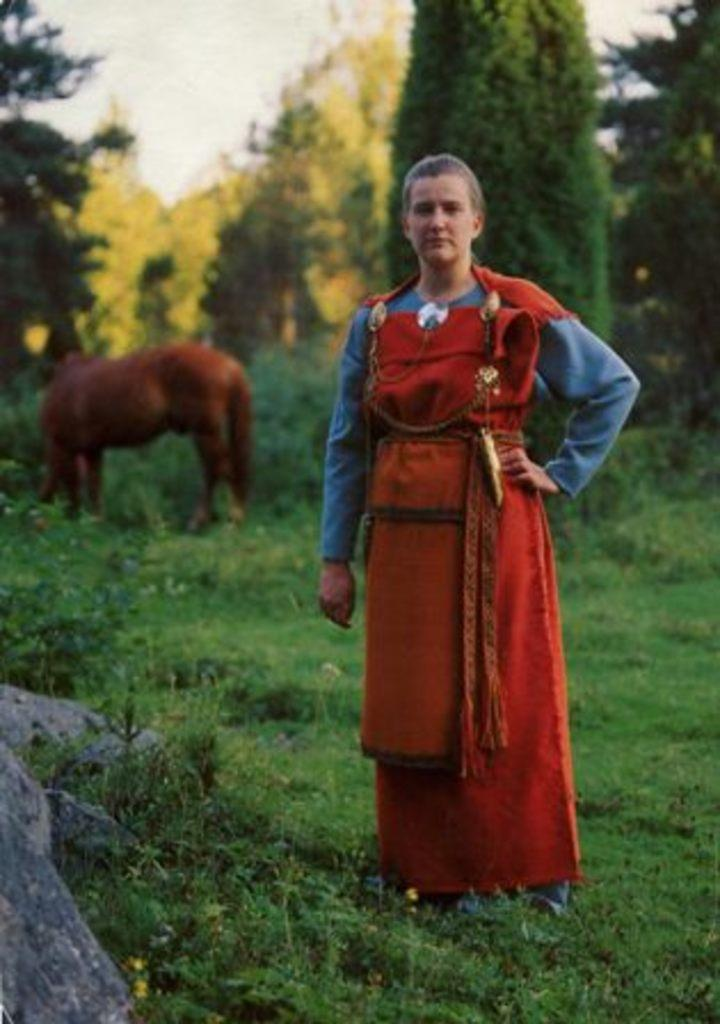What is the lady in the image doing? The lady is standing on the grass in the image. What can be seen in the background of the image? There is a horse, trees, and the sky visible in the background. Can you describe the landscape in the image? The landscape includes grass, trees, and a rock in the left corner. What type of cloth is the horse wearing in the image? There is no horse wearing any cloth in the image. 